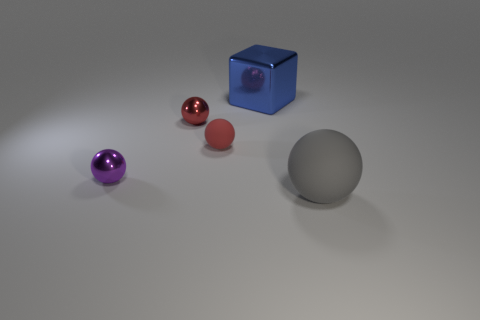Subtract all tiny spheres. How many spheres are left? 1 Add 2 tiny brown matte objects. How many objects exist? 7 Subtract 1 cubes. How many cubes are left? 0 Subtract all gray spheres. How many spheres are left? 3 Subtract 1 gray spheres. How many objects are left? 4 Subtract all spheres. How many objects are left? 1 Subtract all green blocks. Subtract all blue cylinders. How many blocks are left? 1 Subtract all yellow cubes. How many brown spheres are left? 0 Subtract all small purple shiny balls. Subtract all large blue shiny cubes. How many objects are left? 3 Add 4 purple objects. How many purple objects are left? 5 